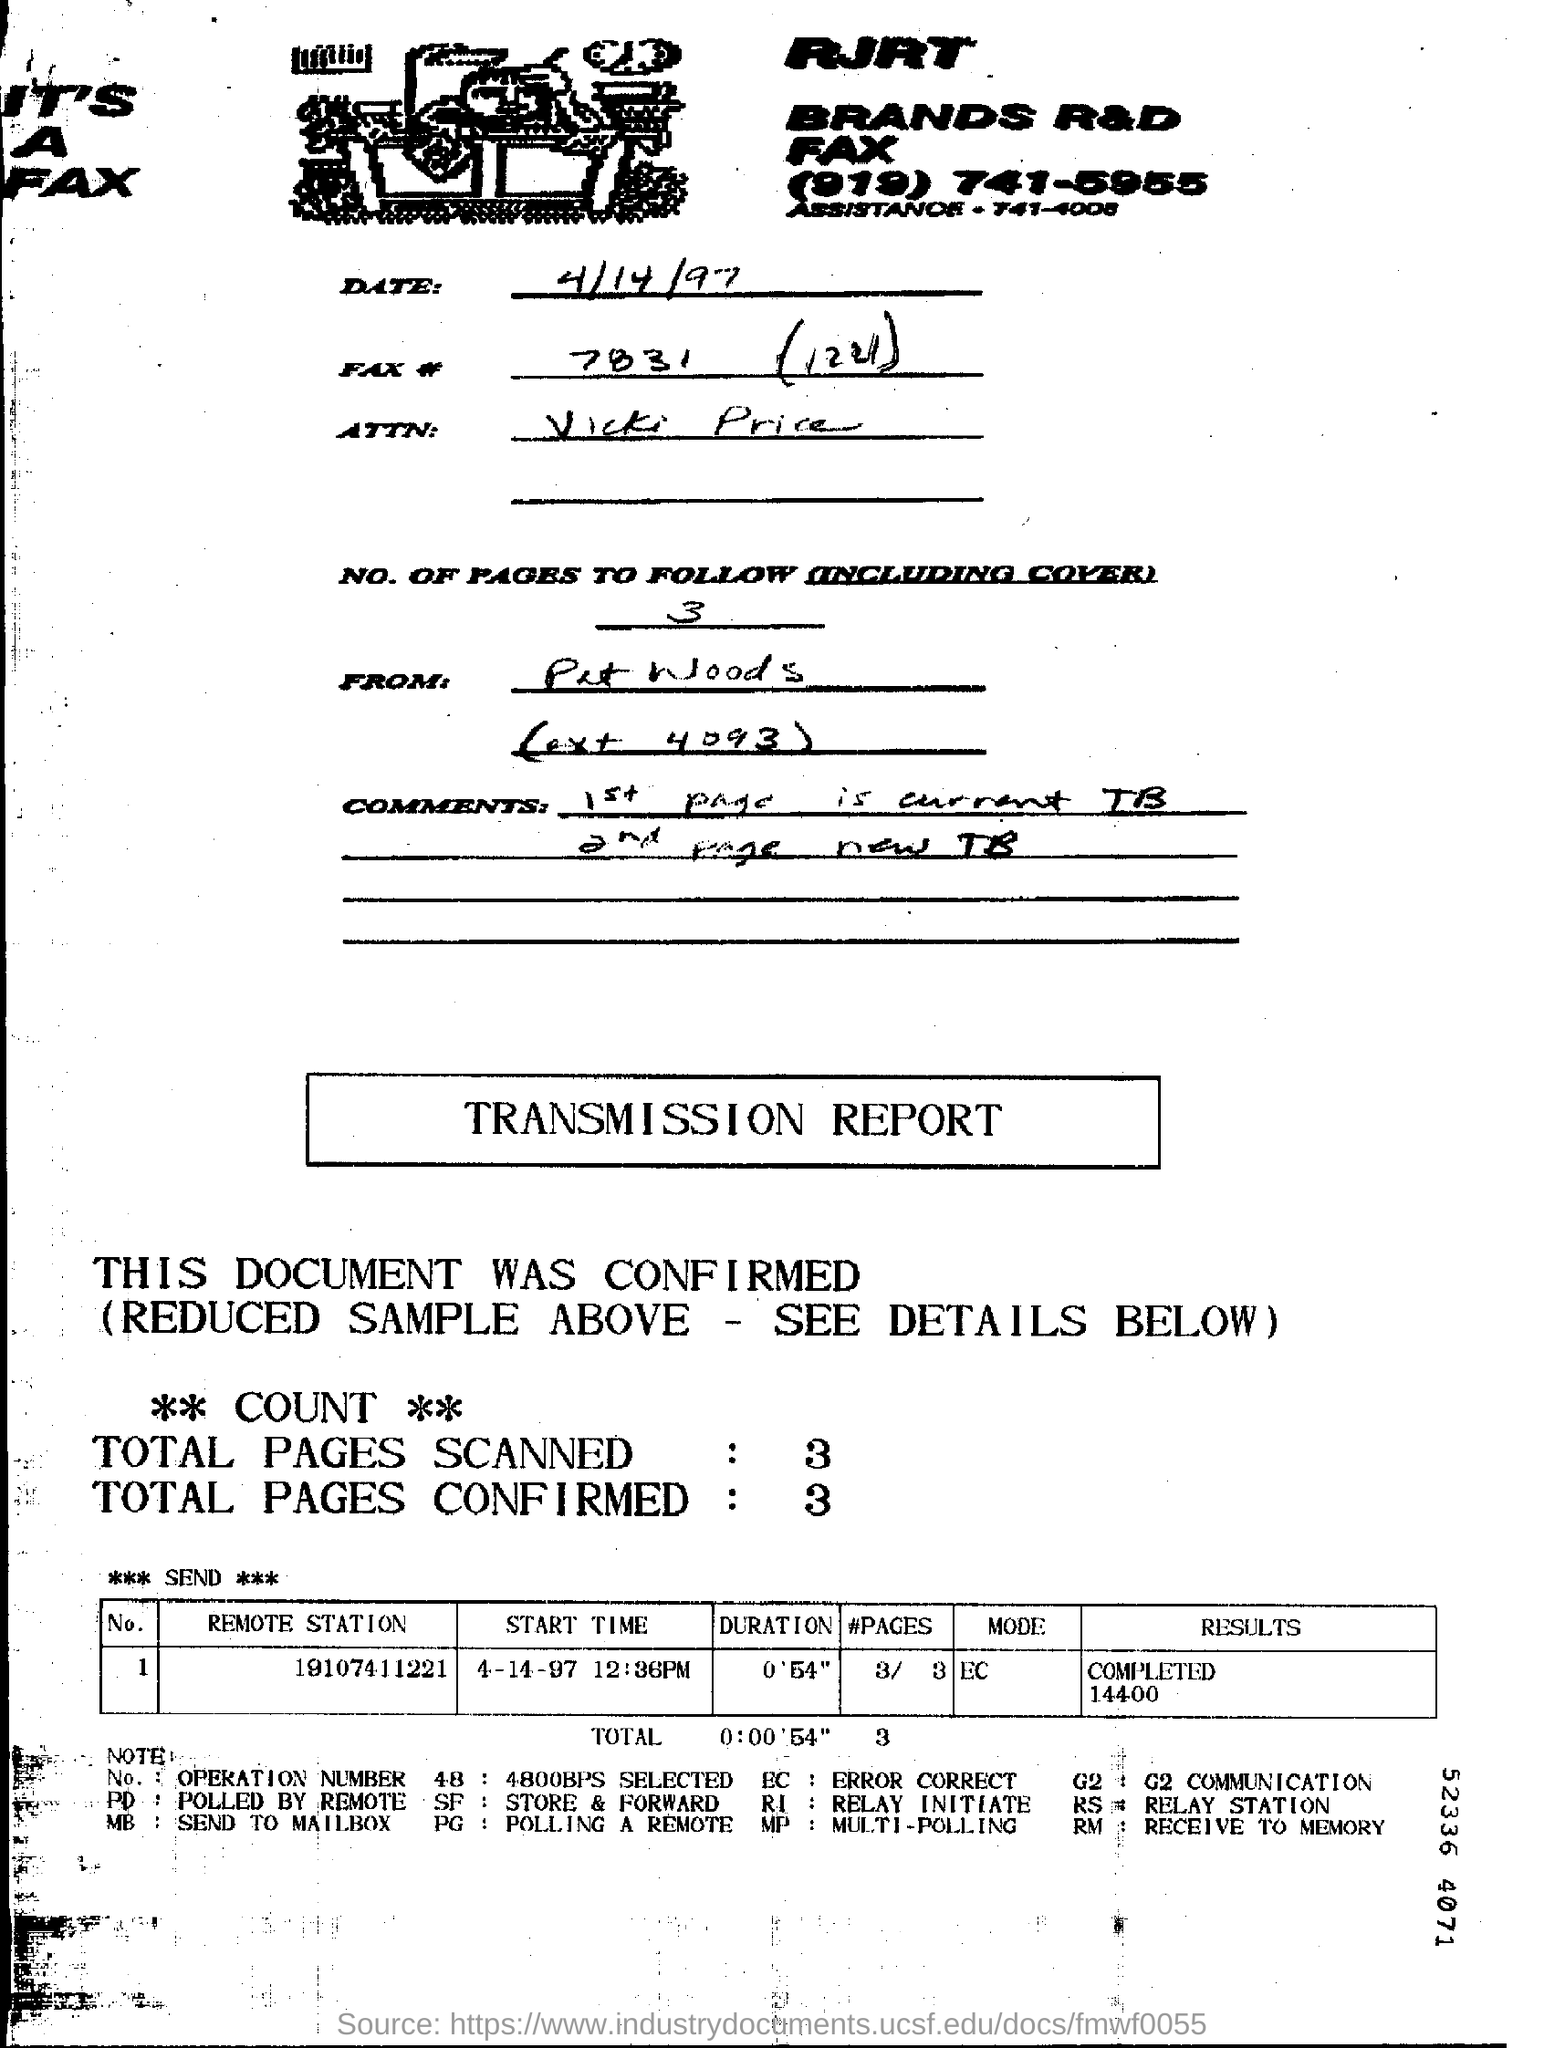Give some essential details in this illustration. The Ext Number of Pat Woods is 4093. The result of the transmission report is that 14400 was completed. The new TB is located on the second page. There are three pages, including the cover, in total. The total number of pages scanned is 3.. 